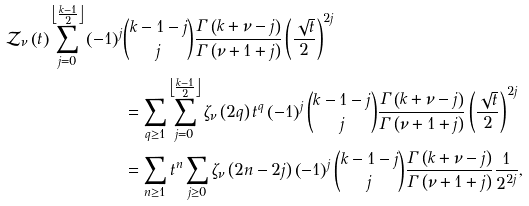<formula> <loc_0><loc_0><loc_500><loc_500>\mathcal { Z } _ { \nu } \left ( t \right ) \sum _ { j = 0 } ^ { \left \lfloor \frac { k - 1 } { 2 } \right \rfloor } \left ( - 1 \right ) ^ { j } & \binom { k - 1 - j } { j } \frac { \Gamma \left ( k + \nu - j \right ) } { \Gamma \left ( \nu + 1 + j \right ) } \left ( \frac { \sqrt { t } } { 2 } \right ) ^ { 2 j } \\ & = \sum _ { q \geq 1 } \sum _ { j = 0 } ^ { \left \lfloor \frac { k - 1 } { 2 } \right \rfloor } \zeta _ { \nu } \left ( 2 q \right ) t ^ { q } \left ( - 1 \right ) ^ { j } \binom { k - 1 - j } { j } \frac { \Gamma \left ( k + \nu - j \right ) } { \Gamma \left ( \nu + 1 + j \right ) } \left ( \frac { \sqrt { t } } { 2 } \right ) ^ { 2 j } \\ & = \sum _ { n \geq 1 } t ^ { n } \sum _ { j \geq 0 } \zeta _ { \nu } \left ( 2 n - 2 j \right ) \left ( - 1 \right ) ^ { j } \binom { k - 1 - j } { j } \frac { \Gamma \left ( k + \nu - j \right ) } { \Gamma \left ( \nu + 1 + j \right ) } \frac { 1 } { 2 ^ { 2 j } } ,</formula> 